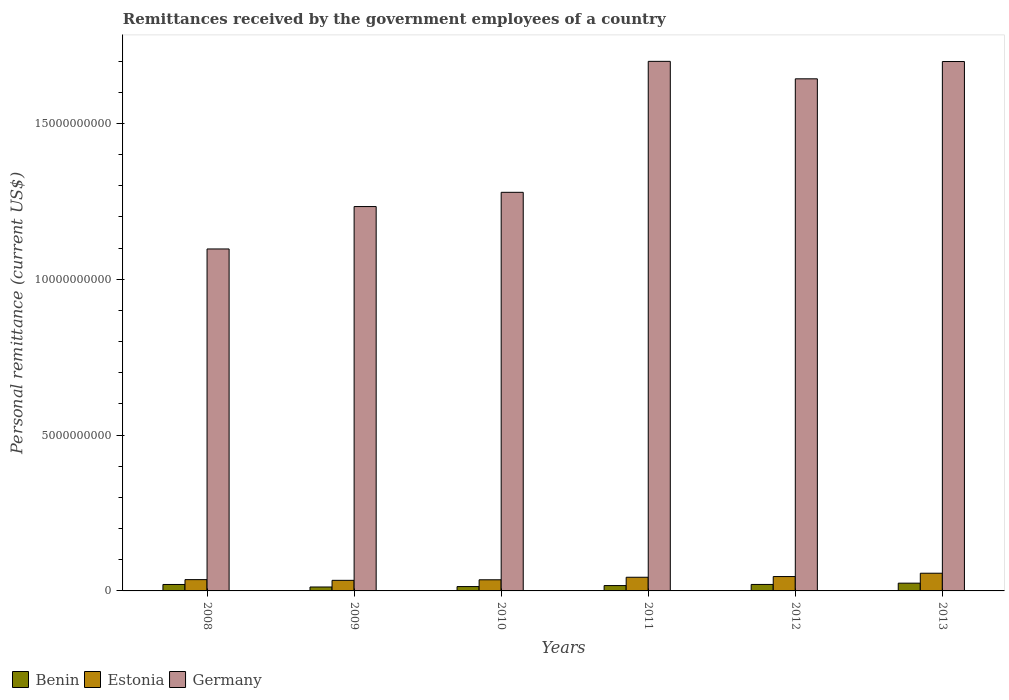Are the number of bars per tick equal to the number of legend labels?
Keep it short and to the point. Yes. Are the number of bars on each tick of the X-axis equal?
Your answer should be very brief. Yes. In how many cases, is the number of bars for a given year not equal to the number of legend labels?
Ensure brevity in your answer.  0. What is the remittances received by the government employees in Benin in 2009?
Give a very brief answer. 1.26e+08. Across all years, what is the maximum remittances received by the government employees in Germany?
Provide a succinct answer. 1.70e+1. Across all years, what is the minimum remittances received by the government employees in Germany?
Offer a terse response. 1.10e+1. In which year was the remittances received by the government employees in Germany maximum?
Offer a very short reply. 2011. What is the total remittances received by the government employees in Benin in the graph?
Ensure brevity in your answer.  1.10e+09. What is the difference between the remittances received by the government employees in Estonia in 2008 and that in 2011?
Make the answer very short. -7.61e+07. What is the difference between the remittances received by the government employees in Estonia in 2009 and the remittances received by the government employees in Germany in 2013?
Make the answer very short. -1.66e+1. What is the average remittances received by the government employees in Estonia per year?
Offer a very short reply. 4.21e+08. In the year 2010, what is the difference between the remittances received by the government employees in Germany and remittances received by the government employees in Benin?
Provide a short and direct response. 1.27e+1. In how many years, is the remittances received by the government employees in Germany greater than 4000000000 US$?
Provide a short and direct response. 6. What is the ratio of the remittances received by the government employees in Estonia in 2009 to that in 2011?
Your answer should be very brief. 0.78. Is the difference between the remittances received by the government employees in Germany in 2012 and 2013 greater than the difference between the remittances received by the government employees in Benin in 2012 and 2013?
Offer a terse response. No. What is the difference between the highest and the second highest remittances received by the government employees in Benin?
Your answer should be compact. 4.10e+07. What is the difference between the highest and the lowest remittances received by the government employees in Germany?
Your answer should be very brief. 6.02e+09. In how many years, is the remittances received by the government employees in Germany greater than the average remittances received by the government employees in Germany taken over all years?
Offer a very short reply. 3. Is the sum of the remittances received by the government employees in Benin in 2008 and 2012 greater than the maximum remittances received by the government employees in Estonia across all years?
Your answer should be compact. No. What does the 3rd bar from the right in 2012 represents?
Make the answer very short. Benin. Is it the case that in every year, the sum of the remittances received by the government employees in Germany and remittances received by the government employees in Benin is greater than the remittances received by the government employees in Estonia?
Your answer should be compact. Yes. Are all the bars in the graph horizontal?
Your answer should be very brief. No. How many years are there in the graph?
Give a very brief answer. 6. Does the graph contain grids?
Your response must be concise. No. Where does the legend appear in the graph?
Keep it short and to the point. Bottom left. How many legend labels are there?
Provide a short and direct response. 3. What is the title of the graph?
Provide a short and direct response. Remittances received by the government employees of a country. Does "Korea (Republic)" appear as one of the legend labels in the graph?
Your answer should be very brief. No. What is the label or title of the X-axis?
Provide a short and direct response. Years. What is the label or title of the Y-axis?
Keep it short and to the point. Personal remittance (current US$). What is the Personal remittance (current US$) in Benin in 2008?
Provide a short and direct response. 2.07e+08. What is the Personal remittance (current US$) in Estonia in 2008?
Give a very brief answer. 3.62e+08. What is the Personal remittance (current US$) of Germany in 2008?
Make the answer very short. 1.10e+1. What is the Personal remittance (current US$) in Benin in 2009?
Provide a succinct answer. 1.26e+08. What is the Personal remittance (current US$) in Estonia in 2009?
Ensure brevity in your answer.  3.40e+08. What is the Personal remittance (current US$) in Germany in 2009?
Keep it short and to the point. 1.23e+1. What is the Personal remittance (current US$) in Benin in 2010?
Make the answer very short. 1.39e+08. What is the Personal remittance (current US$) of Estonia in 2010?
Give a very brief answer. 3.57e+08. What is the Personal remittance (current US$) in Germany in 2010?
Your response must be concise. 1.28e+1. What is the Personal remittance (current US$) in Benin in 2011?
Your answer should be compact. 1.72e+08. What is the Personal remittance (current US$) of Estonia in 2011?
Provide a succinct answer. 4.38e+08. What is the Personal remittance (current US$) of Germany in 2011?
Make the answer very short. 1.70e+1. What is the Personal remittance (current US$) in Benin in 2012?
Ensure brevity in your answer.  2.08e+08. What is the Personal remittance (current US$) in Estonia in 2012?
Your response must be concise. 4.61e+08. What is the Personal remittance (current US$) of Germany in 2012?
Provide a short and direct response. 1.64e+1. What is the Personal remittance (current US$) of Benin in 2013?
Provide a short and direct response. 2.49e+08. What is the Personal remittance (current US$) of Estonia in 2013?
Your answer should be very brief. 5.68e+08. What is the Personal remittance (current US$) in Germany in 2013?
Ensure brevity in your answer.  1.70e+1. Across all years, what is the maximum Personal remittance (current US$) of Benin?
Give a very brief answer. 2.49e+08. Across all years, what is the maximum Personal remittance (current US$) in Estonia?
Ensure brevity in your answer.  5.68e+08. Across all years, what is the maximum Personal remittance (current US$) in Germany?
Keep it short and to the point. 1.70e+1. Across all years, what is the minimum Personal remittance (current US$) of Benin?
Your answer should be compact. 1.26e+08. Across all years, what is the minimum Personal remittance (current US$) in Estonia?
Your answer should be compact. 3.40e+08. Across all years, what is the minimum Personal remittance (current US$) in Germany?
Offer a terse response. 1.10e+1. What is the total Personal remittance (current US$) in Benin in the graph?
Make the answer very short. 1.10e+09. What is the total Personal remittance (current US$) in Estonia in the graph?
Your answer should be compact. 2.53e+09. What is the total Personal remittance (current US$) of Germany in the graph?
Your answer should be compact. 8.65e+1. What is the difference between the Personal remittance (current US$) of Benin in 2008 and that in 2009?
Your answer should be compact. 8.11e+07. What is the difference between the Personal remittance (current US$) in Estonia in 2008 and that in 2009?
Provide a short and direct response. 2.25e+07. What is the difference between the Personal remittance (current US$) in Germany in 2008 and that in 2009?
Offer a terse response. -1.36e+09. What is the difference between the Personal remittance (current US$) in Benin in 2008 and that in 2010?
Your response must be concise. 6.76e+07. What is the difference between the Personal remittance (current US$) of Estonia in 2008 and that in 2010?
Your answer should be very brief. 5.10e+06. What is the difference between the Personal remittance (current US$) of Germany in 2008 and that in 2010?
Your response must be concise. -1.82e+09. What is the difference between the Personal remittance (current US$) of Benin in 2008 and that in 2011?
Your answer should be compact. 3.51e+07. What is the difference between the Personal remittance (current US$) in Estonia in 2008 and that in 2011?
Give a very brief answer. -7.61e+07. What is the difference between the Personal remittance (current US$) of Germany in 2008 and that in 2011?
Make the answer very short. -6.02e+09. What is the difference between the Personal remittance (current US$) in Benin in 2008 and that in 2012?
Offer a very short reply. -7.50e+05. What is the difference between the Personal remittance (current US$) of Estonia in 2008 and that in 2012?
Provide a succinct answer. -9.86e+07. What is the difference between the Personal remittance (current US$) of Germany in 2008 and that in 2012?
Give a very brief answer. -5.46e+09. What is the difference between the Personal remittance (current US$) of Benin in 2008 and that in 2013?
Your answer should be compact. -4.17e+07. What is the difference between the Personal remittance (current US$) of Estonia in 2008 and that in 2013?
Provide a short and direct response. -2.05e+08. What is the difference between the Personal remittance (current US$) in Germany in 2008 and that in 2013?
Your response must be concise. -6.02e+09. What is the difference between the Personal remittance (current US$) in Benin in 2009 and that in 2010?
Your answer should be very brief. -1.35e+07. What is the difference between the Personal remittance (current US$) of Estonia in 2009 and that in 2010?
Make the answer very short. -1.74e+07. What is the difference between the Personal remittance (current US$) in Germany in 2009 and that in 2010?
Your answer should be compact. -4.57e+08. What is the difference between the Personal remittance (current US$) in Benin in 2009 and that in 2011?
Your answer should be compact. -4.60e+07. What is the difference between the Personal remittance (current US$) in Estonia in 2009 and that in 2011?
Ensure brevity in your answer.  -9.86e+07. What is the difference between the Personal remittance (current US$) in Germany in 2009 and that in 2011?
Provide a succinct answer. -4.66e+09. What is the difference between the Personal remittance (current US$) in Benin in 2009 and that in 2012?
Provide a short and direct response. -8.18e+07. What is the difference between the Personal remittance (current US$) of Estonia in 2009 and that in 2012?
Provide a short and direct response. -1.21e+08. What is the difference between the Personal remittance (current US$) in Germany in 2009 and that in 2012?
Your answer should be very brief. -4.10e+09. What is the difference between the Personal remittance (current US$) in Benin in 2009 and that in 2013?
Give a very brief answer. -1.23e+08. What is the difference between the Personal remittance (current US$) in Estonia in 2009 and that in 2013?
Give a very brief answer. -2.28e+08. What is the difference between the Personal remittance (current US$) of Germany in 2009 and that in 2013?
Your response must be concise. -4.65e+09. What is the difference between the Personal remittance (current US$) in Benin in 2010 and that in 2011?
Provide a succinct answer. -3.25e+07. What is the difference between the Personal remittance (current US$) in Estonia in 2010 and that in 2011?
Your answer should be very brief. -8.12e+07. What is the difference between the Personal remittance (current US$) in Germany in 2010 and that in 2011?
Ensure brevity in your answer.  -4.20e+09. What is the difference between the Personal remittance (current US$) of Benin in 2010 and that in 2012?
Keep it short and to the point. -6.83e+07. What is the difference between the Personal remittance (current US$) in Estonia in 2010 and that in 2012?
Keep it short and to the point. -1.04e+08. What is the difference between the Personal remittance (current US$) in Germany in 2010 and that in 2012?
Offer a very short reply. -3.64e+09. What is the difference between the Personal remittance (current US$) of Benin in 2010 and that in 2013?
Offer a very short reply. -1.09e+08. What is the difference between the Personal remittance (current US$) in Estonia in 2010 and that in 2013?
Ensure brevity in your answer.  -2.10e+08. What is the difference between the Personal remittance (current US$) in Germany in 2010 and that in 2013?
Your answer should be compact. -4.20e+09. What is the difference between the Personal remittance (current US$) in Benin in 2011 and that in 2012?
Your answer should be very brief. -3.58e+07. What is the difference between the Personal remittance (current US$) in Estonia in 2011 and that in 2012?
Ensure brevity in your answer.  -2.25e+07. What is the difference between the Personal remittance (current US$) of Germany in 2011 and that in 2012?
Your answer should be compact. 5.61e+08. What is the difference between the Personal remittance (current US$) of Benin in 2011 and that in 2013?
Your answer should be very brief. -7.68e+07. What is the difference between the Personal remittance (current US$) of Estonia in 2011 and that in 2013?
Provide a short and direct response. -1.29e+08. What is the difference between the Personal remittance (current US$) of Germany in 2011 and that in 2013?
Offer a terse response. 5.22e+06. What is the difference between the Personal remittance (current US$) in Benin in 2012 and that in 2013?
Offer a very short reply. -4.10e+07. What is the difference between the Personal remittance (current US$) in Estonia in 2012 and that in 2013?
Give a very brief answer. -1.07e+08. What is the difference between the Personal remittance (current US$) in Germany in 2012 and that in 2013?
Provide a short and direct response. -5.56e+08. What is the difference between the Personal remittance (current US$) of Benin in 2008 and the Personal remittance (current US$) of Estonia in 2009?
Your answer should be compact. -1.33e+08. What is the difference between the Personal remittance (current US$) of Benin in 2008 and the Personal remittance (current US$) of Germany in 2009?
Offer a terse response. -1.21e+1. What is the difference between the Personal remittance (current US$) of Estonia in 2008 and the Personal remittance (current US$) of Germany in 2009?
Make the answer very short. -1.20e+1. What is the difference between the Personal remittance (current US$) in Benin in 2008 and the Personal remittance (current US$) in Estonia in 2010?
Offer a terse response. -1.50e+08. What is the difference between the Personal remittance (current US$) in Benin in 2008 and the Personal remittance (current US$) in Germany in 2010?
Keep it short and to the point. -1.26e+1. What is the difference between the Personal remittance (current US$) in Estonia in 2008 and the Personal remittance (current US$) in Germany in 2010?
Provide a succinct answer. -1.24e+1. What is the difference between the Personal remittance (current US$) in Benin in 2008 and the Personal remittance (current US$) in Estonia in 2011?
Provide a short and direct response. -2.31e+08. What is the difference between the Personal remittance (current US$) of Benin in 2008 and the Personal remittance (current US$) of Germany in 2011?
Provide a succinct answer. -1.68e+1. What is the difference between the Personal remittance (current US$) in Estonia in 2008 and the Personal remittance (current US$) in Germany in 2011?
Provide a short and direct response. -1.66e+1. What is the difference between the Personal remittance (current US$) of Benin in 2008 and the Personal remittance (current US$) of Estonia in 2012?
Offer a very short reply. -2.54e+08. What is the difference between the Personal remittance (current US$) in Benin in 2008 and the Personal remittance (current US$) in Germany in 2012?
Offer a terse response. -1.62e+1. What is the difference between the Personal remittance (current US$) of Estonia in 2008 and the Personal remittance (current US$) of Germany in 2012?
Ensure brevity in your answer.  -1.61e+1. What is the difference between the Personal remittance (current US$) in Benin in 2008 and the Personal remittance (current US$) in Estonia in 2013?
Ensure brevity in your answer.  -3.61e+08. What is the difference between the Personal remittance (current US$) of Benin in 2008 and the Personal remittance (current US$) of Germany in 2013?
Provide a succinct answer. -1.68e+1. What is the difference between the Personal remittance (current US$) in Estonia in 2008 and the Personal remittance (current US$) in Germany in 2013?
Ensure brevity in your answer.  -1.66e+1. What is the difference between the Personal remittance (current US$) in Benin in 2009 and the Personal remittance (current US$) in Estonia in 2010?
Your response must be concise. -2.31e+08. What is the difference between the Personal remittance (current US$) of Benin in 2009 and the Personal remittance (current US$) of Germany in 2010?
Your response must be concise. -1.27e+1. What is the difference between the Personal remittance (current US$) in Estonia in 2009 and the Personal remittance (current US$) in Germany in 2010?
Make the answer very short. -1.25e+1. What is the difference between the Personal remittance (current US$) in Benin in 2009 and the Personal remittance (current US$) in Estonia in 2011?
Give a very brief answer. -3.12e+08. What is the difference between the Personal remittance (current US$) of Benin in 2009 and the Personal remittance (current US$) of Germany in 2011?
Your response must be concise. -1.69e+1. What is the difference between the Personal remittance (current US$) in Estonia in 2009 and the Personal remittance (current US$) in Germany in 2011?
Keep it short and to the point. -1.67e+1. What is the difference between the Personal remittance (current US$) in Benin in 2009 and the Personal remittance (current US$) in Estonia in 2012?
Your answer should be compact. -3.35e+08. What is the difference between the Personal remittance (current US$) in Benin in 2009 and the Personal remittance (current US$) in Germany in 2012?
Your answer should be compact. -1.63e+1. What is the difference between the Personal remittance (current US$) in Estonia in 2009 and the Personal remittance (current US$) in Germany in 2012?
Keep it short and to the point. -1.61e+1. What is the difference between the Personal remittance (current US$) of Benin in 2009 and the Personal remittance (current US$) of Estonia in 2013?
Make the answer very short. -4.42e+08. What is the difference between the Personal remittance (current US$) of Benin in 2009 and the Personal remittance (current US$) of Germany in 2013?
Ensure brevity in your answer.  -1.69e+1. What is the difference between the Personal remittance (current US$) of Estonia in 2009 and the Personal remittance (current US$) of Germany in 2013?
Offer a terse response. -1.66e+1. What is the difference between the Personal remittance (current US$) in Benin in 2010 and the Personal remittance (current US$) in Estonia in 2011?
Keep it short and to the point. -2.99e+08. What is the difference between the Personal remittance (current US$) of Benin in 2010 and the Personal remittance (current US$) of Germany in 2011?
Provide a short and direct response. -1.69e+1. What is the difference between the Personal remittance (current US$) in Estonia in 2010 and the Personal remittance (current US$) in Germany in 2011?
Make the answer very short. -1.66e+1. What is the difference between the Personal remittance (current US$) of Benin in 2010 and the Personal remittance (current US$) of Estonia in 2012?
Keep it short and to the point. -3.21e+08. What is the difference between the Personal remittance (current US$) of Benin in 2010 and the Personal remittance (current US$) of Germany in 2012?
Provide a short and direct response. -1.63e+1. What is the difference between the Personal remittance (current US$) of Estonia in 2010 and the Personal remittance (current US$) of Germany in 2012?
Your answer should be compact. -1.61e+1. What is the difference between the Personal remittance (current US$) of Benin in 2010 and the Personal remittance (current US$) of Estonia in 2013?
Provide a short and direct response. -4.28e+08. What is the difference between the Personal remittance (current US$) in Benin in 2010 and the Personal remittance (current US$) in Germany in 2013?
Your answer should be compact. -1.68e+1. What is the difference between the Personal remittance (current US$) of Estonia in 2010 and the Personal remittance (current US$) of Germany in 2013?
Your answer should be very brief. -1.66e+1. What is the difference between the Personal remittance (current US$) in Benin in 2011 and the Personal remittance (current US$) in Estonia in 2012?
Your answer should be very brief. -2.89e+08. What is the difference between the Personal remittance (current US$) of Benin in 2011 and the Personal remittance (current US$) of Germany in 2012?
Ensure brevity in your answer.  -1.63e+1. What is the difference between the Personal remittance (current US$) in Estonia in 2011 and the Personal remittance (current US$) in Germany in 2012?
Keep it short and to the point. -1.60e+1. What is the difference between the Personal remittance (current US$) of Benin in 2011 and the Personal remittance (current US$) of Estonia in 2013?
Provide a short and direct response. -3.96e+08. What is the difference between the Personal remittance (current US$) of Benin in 2011 and the Personal remittance (current US$) of Germany in 2013?
Give a very brief answer. -1.68e+1. What is the difference between the Personal remittance (current US$) of Estonia in 2011 and the Personal remittance (current US$) of Germany in 2013?
Provide a succinct answer. -1.66e+1. What is the difference between the Personal remittance (current US$) of Benin in 2012 and the Personal remittance (current US$) of Estonia in 2013?
Make the answer very short. -3.60e+08. What is the difference between the Personal remittance (current US$) of Benin in 2012 and the Personal remittance (current US$) of Germany in 2013?
Offer a very short reply. -1.68e+1. What is the difference between the Personal remittance (current US$) in Estonia in 2012 and the Personal remittance (current US$) in Germany in 2013?
Your answer should be very brief. -1.65e+1. What is the average Personal remittance (current US$) in Benin per year?
Make the answer very short. 1.83e+08. What is the average Personal remittance (current US$) of Estonia per year?
Offer a very short reply. 4.21e+08. What is the average Personal remittance (current US$) in Germany per year?
Ensure brevity in your answer.  1.44e+1. In the year 2008, what is the difference between the Personal remittance (current US$) of Benin and Personal remittance (current US$) of Estonia?
Provide a short and direct response. -1.55e+08. In the year 2008, what is the difference between the Personal remittance (current US$) of Benin and Personal remittance (current US$) of Germany?
Your answer should be compact. -1.08e+1. In the year 2008, what is the difference between the Personal remittance (current US$) in Estonia and Personal remittance (current US$) in Germany?
Make the answer very short. -1.06e+1. In the year 2009, what is the difference between the Personal remittance (current US$) of Benin and Personal remittance (current US$) of Estonia?
Your answer should be compact. -2.14e+08. In the year 2009, what is the difference between the Personal remittance (current US$) of Benin and Personal remittance (current US$) of Germany?
Give a very brief answer. -1.22e+1. In the year 2009, what is the difference between the Personal remittance (current US$) in Estonia and Personal remittance (current US$) in Germany?
Give a very brief answer. -1.20e+1. In the year 2010, what is the difference between the Personal remittance (current US$) of Benin and Personal remittance (current US$) of Estonia?
Provide a succinct answer. -2.18e+08. In the year 2010, what is the difference between the Personal remittance (current US$) of Benin and Personal remittance (current US$) of Germany?
Provide a short and direct response. -1.27e+1. In the year 2010, what is the difference between the Personal remittance (current US$) in Estonia and Personal remittance (current US$) in Germany?
Give a very brief answer. -1.24e+1. In the year 2011, what is the difference between the Personal remittance (current US$) in Benin and Personal remittance (current US$) in Estonia?
Your response must be concise. -2.66e+08. In the year 2011, what is the difference between the Personal remittance (current US$) of Benin and Personal remittance (current US$) of Germany?
Offer a terse response. -1.68e+1. In the year 2011, what is the difference between the Personal remittance (current US$) of Estonia and Personal remittance (current US$) of Germany?
Offer a terse response. -1.66e+1. In the year 2012, what is the difference between the Personal remittance (current US$) of Benin and Personal remittance (current US$) of Estonia?
Keep it short and to the point. -2.53e+08. In the year 2012, what is the difference between the Personal remittance (current US$) in Benin and Personal remittance (current US$) in Germany?
Ensure brevity in your answer.  -1.62e+1. In the year 2012, what is the difference between the Personal remittance (current US$) in Estonia and Personal remittance (current US$) in Germany?
Offer a terse response. -1.60e+1. In the year 2013, what is the difference between the Personal remittance (current US$) of Benin and Personal remittance (current US$) of Estonia?
Give a very brief answer. -3.19e+08. In the year 2013, what is the difference between the Personal remittance (current US$) in Benin and Personal remittance (current US$) in Germany?
Your response must be concise. -1.67e+1. In the year 2013, what is the difference between the Personal remittance (current US$) in Estonia and Personal remittance (current US$) in Germany?
Offer a very short reply. -1.64e+1. What is the ratio of the Personal remittance (current US$) of Benin in 2008 to that in 2009?
Your response must be concise. 1.64. What is the ratio of the Personal remittance (current US$) in Estonia in 2008 to that in 2009?
Offer a very short reply. 1.07. What is the ratio of the Personal remittance (current US$) of Germany in 2008 to that in 2009?
Give a very brief answer. 0.89. What is the ratio of the Personal remittance (current US$) in Benin in 2008 to that in 2010?
Your response must be concise. 1.48. What is the ratio of the Personal remittance (current US$) of Estonia in 2008 to that in 2010?
Ensure brevity in your answer.  1.01. What is the ratio of the Personal remittance (current US$) of Germany in 2008 to that in 2010?
Your answer should be compact. 0.86. What is the ratio of the Personal remittance (current US$) of Benin in 2008 to that in 2011?
Your answer should be compact. 1.2. What is the ratio of the Personal remittance (current US$) in Estonia in 2008 to that in 2011?
Keep it short and to the point. 0.83. What is the ratio of the Personal remittance (current US$) in Germany in 2008 to that in 2011?
Your response must be concise. 0.65. What is the ratio of the Personal remittance (current US$) in Estonia in 2008 to that in 2012?
Give a very brief answer. 0.79. What is the ratio of the Personal remittance (current US$) of Germany in 2008 to that in 2012?
Offer a very short reply. 0.67. What is the ratio of the Personal remittance (current US$) in Benin in 2008 to that in 2013?
Offer a terse response. 0.83. What is the ratio of the Personal remittance (current US$) in Estonia in 2008 to that in 2013?
Keep it short and to the point. 0.64. What is the ratio of the Personal remittance (current US$) of Germany in 2008 to that in 2013?
Offer a very short reply. 0.65. What is the ratio of the Personal remittance (current US$) in Benin in 2009 to that in 2010?
Ensure brevity in your answer.  0.9. What is the ratio of the Personal remittance (current US$) of Estonia in 2009 to that in 2010?
Your response must be concise. 0.95. What is the ratio of the Personal remittance (current US$) of Germany in 2009 to that in 2010?
Keep it short and to the point. 0.96. What is the ratio of the Personal remittance (current US$) in Benin in 2009 to that in 2011?
Keep it short and to the point. 0.73. What is the ratio of the Personal remittance (current US$) in Estonia in 2009 to that in 2011?
Provide a short and direct response. 0.78. What is the ratio of the Personal remittance (current US$) in Germany in 2009 to that in 2011?
Your response must be concise. 0.73. What is the ratio of the Personal remittance (current US$) in Benin in 2009 to that in 2012?
Give a very brief answer. 0.61. What is the ratio of the Personal remittance (current US$) of Estonia in 2009 to that in 2012?
Give a very brief answer. 0.74. What is the ratio of the Personal remittance (current US$) of Germany in 2009 to that in 2012?
Make the answer very short. 0.75. What is the ratio of the Personal remittance (current US$) of Benin in 2009 to that in 2013?
Offer a very short reply. 0.51. What is the ratio of the Personal remittance (current US$) in Estonia in 2009 to that in 2013?
Offer a very short reply. 0.6. What is the ratio of the Personal remittance (current US$) of Germany in 2009 to that in 2013?
Give a very brief answer. 0.73. What is the ratio of the Personal remittance (current US$) in Benin in 2010 to that in 2011?
Offer a terse response. 0.81. What is the ratio of the Personal remittance (current US$) of Estonia in 2010 to that in 2011?
Make the answer very short. 0.81. What is the ratio of the Personal remittance (current US$) in Germany in 2010 to that in 2011?
Give a very brief answer. 0.75. What is the ratio of the Personal remittance (current US$) of Benin in 2010 to that in 2012?
Give a very brief answer. 0.67. What is the ratio of the Personal remittance (current US$) in Estonia in 2010 to that in 2012?
Provide a succinct answer. 0.78. What is the ratio of the Personal remittance (current US$) of Germany in 2010 to that in 2012?
Make the answer very short. 0.78. What is the ratio of the Personal remittance (current US$) in Benin in 2010 to that in 2013?
Keep it short and to the point. 0.56. What is the ratio of the Personal remittance (current US$) in Estonia in 2010 to that in 2013?
Offer a terse response. 0.63. What is the ratio of the Personal remittance (current US$) in Germany in 2010 to that in 2013?
Offer a very short reply. 0.75. What is the ratio of the Personal remittance (current US$) of Benin in 2011 to that in 2012?
Keep it short and to the point. 0.83. What is the ratio of the Personal remittance (current US$) in Estonia in 2011 to that in 2012?
Give a very brief answer. 0.95. What is the ratio of the Personal remittance (current US$) in Germany in 2011 to that in 2012?
Make the answer very short. 1.03. What is the ratio of the Personal remittance (current US$) in Benin in 2011 to that in 2013?
Provide a succinct answer. 0.69. What is the ratio of the Personal remittance (current US$) in Estonia in 2011 to that in 2013?
Keep it short and to the point. 0.77. What is the ratio of the Personal remittance (current US$) of Benin in 2012 to that in 2013?
Your answer should be compact. 0.84. What is the ratio of the Personal remittance (current US$) of Estonia in 2012 to that in 2013?
Your response must be concise. 0.81. What is the ratio of the Personal remittance (current US$) of Germany in 2012 to that in 2013?
Offer a very short reply. 0.97. What is the difference between the highest and the second highest Personal remittance (current US$) in Benin?
Provide a succinct answer. 4.10e+07. What is the difference between the highest and the second highest Personal remittance (current US$) of Estonia?
Provide a succinct answer. 1.07e+08. What is the difference between the highest and the second highest Personal remittance (current US$) in Germany?
Give a very brief answer. 5.22e+06. What is the difference between the highest and the lowest Personal remittance (current US$) in Benin?
Provide a succinct answer. 1.23e+08. What is the difference between the highest and the lowest Personal remittance (current US$) of Estonia?
Provide a short and direct response. 2.28e+08. What is the difference between the highest and the lowest Personal remittance (current US$) of Germany?
Your answer should be very brief. 6.02e+09. 